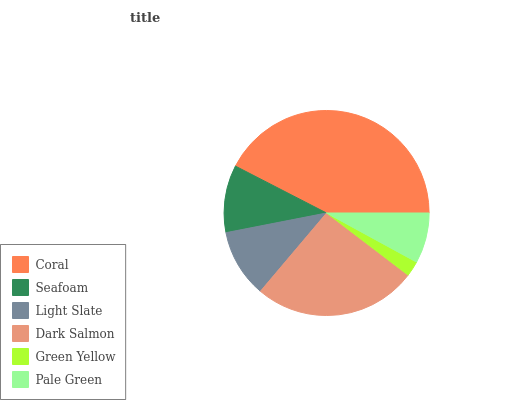Is Green Yellow the minimum?
Answer yes or no. Yes. Is Coral the maximum?
Answer yes or no. Yes. Is Seafoam the minimum?
Answer yes or no. No. Is Seafoam the maximum?
Answer yes or no. No. Is Coral greater than Seafoam?
Answer yes or no. Yes. Is Seafoam less than Coral?
Answer yes or no. Yes. Is Seafoam greater than Coral?
Answer yes or no. No. Is Coral less than Seafoam?
Answer yes or no. No. Is Light Slate the high median?
Answer yes or no. Yes. Is Seafoam the low median?
Answer yes or no. Yes. Is Coral the high median?
Answer yes or no. No. Is Green Yellow the low median?
Answer yes or no. No. 